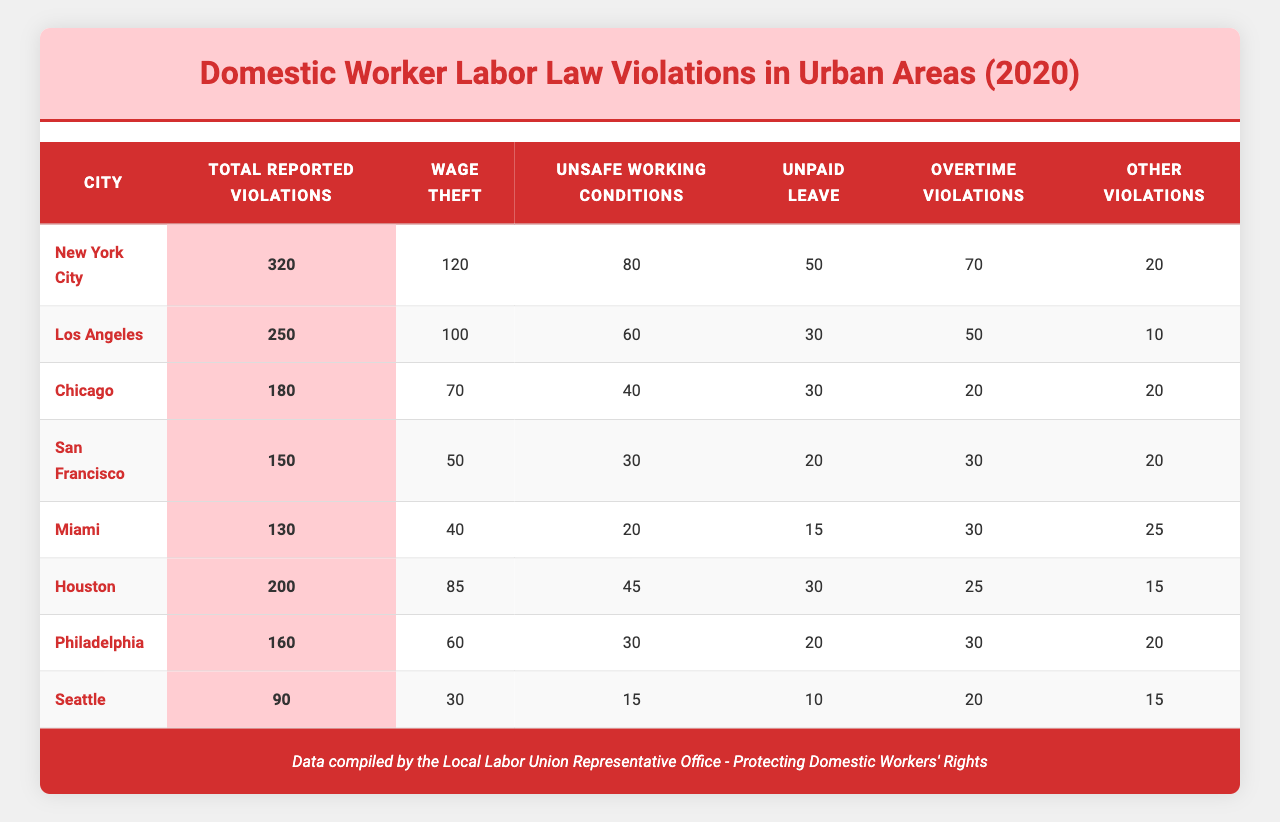What city reported the highest total number of labor law violations? By scanning the "Total Reported Violations" column, I can see that New York City has the highest number at 320.
Answer: New York City How many wage theft violations were reported in Los Angeles? I look at the row for Los Angeles and find the "Wage Theft" column, which lists 100 violations.
Answer: 100 Which city experienced the least violations in the category of unsafe working conditions? Seattle has the lowest count of unsafe working conditions at 15 violations, as indicated in the respective column.
Answer: Seattle What is the total number of violations reported across all cities? I sum the "Total Reported Violations" for each city: (320 + 250 + 180 + 150 + 130 + 200 + 160 + 90) = 1,520.
Answer: 1,520 In which city did unpaid leave violations exceed 20? Checking the "Unpaid Leave" column, I see that New York City (50), Los Angeles (30), Chicago (30), Houston (30), Philadelphia (20) all exceed 20, while others do not.
Answer: New York City, Los Angeles, Chicago, Houston What percentage of total reported violations in Chicago were due to wage theft? In Chicago, wage theft violations are 70 out of the total 180. I calculate the percentage: (70/180) * 100 = 38.89%.
Answer: 38.89% How many more total violations were reported in Miami compared to San Francisco? I subtract the total for San Francisco (150) from that of Miami (130), which gives me 130 - 150 = -20, indicating that Miami reported 20 fewer violations.
Answer: Miami reported 20 fewer violations than San Francisco Which city has the highest incidence of overtime violations? I check the "Overtime Violations" column; New York City has 70 violations, which is higher than any other city.
Answer: New York City Was there any city that reported zero violations in the "Other Violations" category? Reviewing the "Other Violations" column shows that all cities reported violations greater than zero.
Answer: No What is the average number of wage theft violations reported across all cities? I sum the wage theft violations: (120 + 100 + 70 + 50 + 40 + 85 + 60 + 30) = 555. Then I divide by the number of cities (8): 555/8 = 69.375, approximately 69.38.
Answer: 69.38 